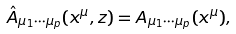Convert formula to latex. <formula><loc_0><loc_0><loc_500><loc_500>\hat { A } _ { \mu _ { 1 } \cdots \mu _ { p } } ( x ^ { \mu } , z ) = A _ { \mu _ { 1 } \cdots \mu _ { p } } ( x ^ { \mu } ) ,</formula> 